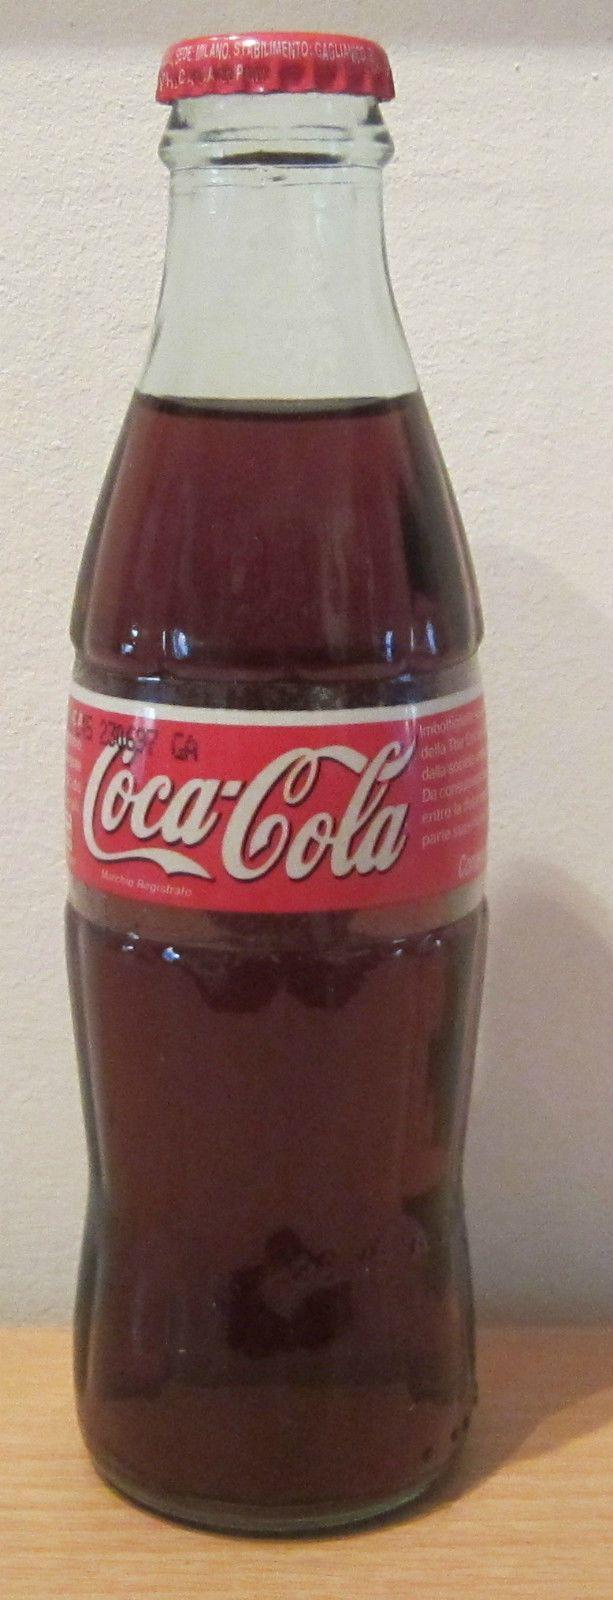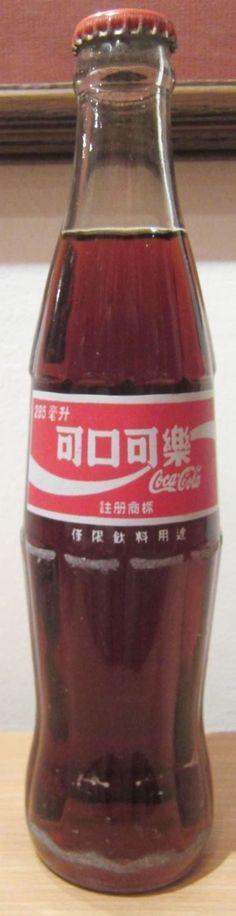The first image is the image on the left, the second image is the image on the right. Examine the images to the left and right. Is the description "Each image shows one bottle with a cap on it, and one image features a bottle that tapers from its base, has a textured surface but no label, and contains a red liquid." accurate? Answer yes or no. No. The first image is the image on the left, the second image is the image on the right. Assess this claim about the two images: "There are labels on each of the bottles.". Correct or not? Answer yes or no. Yes. 